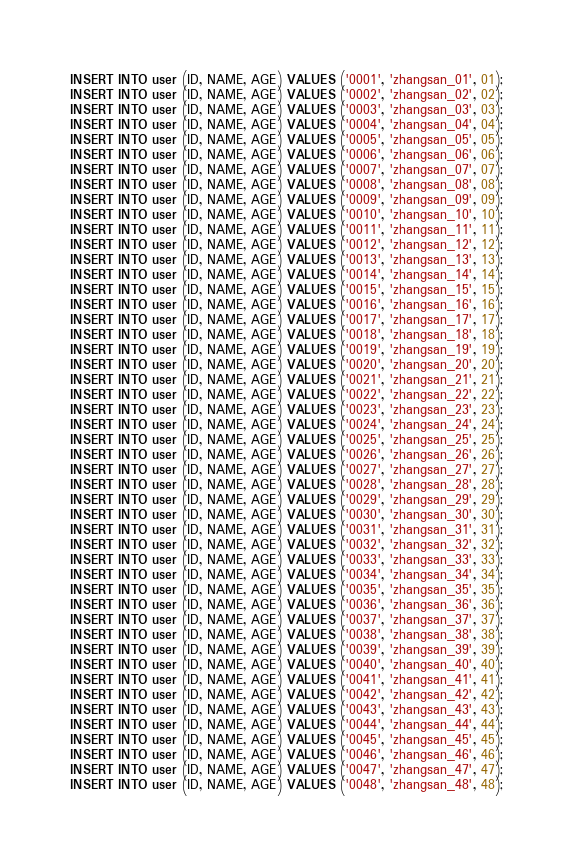<code> <loc_0><loc_0><loc_500><loc_500><_SQL_>INSERT INTO user (ID, NAME, AGE) VALUES ('0001', 'zhangsan_01', 01);
INSERT INTO user (ID, NAME, AGE) VALUES ('0002', 'zhangsan_02', 02);
INSERT INTO user (ID, NAME, AGE) VALUES ('0003', 'zhangsan_03', 03);
INSERT INTO user (ID, NAME, AGE) VALUES ('0004', 'zhangsan_04', 04);
INSERT INTO user (ID, NAME, AGE) VALUES ('0005', 'zhangsan_05', 05);
INSERT INTO user (ID, NAME, AGE) VALUES ('0006', 'zhangsan_06', 06);
INSERT INTO user (ID, NAME, AGE) VALUES ('0007', 'zhangsan_07', 07);
INSERT INTO user (ID, NAME, AGE) VALUES ('0008', 'zhangsan_08', 08);
INSERT INTO user (ID, NAME, AGE) VALUES ('0009', 'zhangsan_09', 09);
INSERT INTO user (ID, NAME, AGE) VALUES ('0010', 'zhangsan_10', 10);
INSERT INTO user (ID, NAME, AGE) VALUES ('0011', 'zhangsan_11', 11);
INSERT INTO user (ID, NAME, AGE) VALUES ('0012', 'zhangsan_12', 12);
INSERT INTO user (ID, NAME, AGE) VALUES ('0013', 'zhangsan_13', 13);
INSERT INTO user (ID, NAME, AGE) VALUES ('0014', 'zhangsan_14', 14);
INSERT INTO user (ID, NAME, AGE) VALUES ('0015', 'zhangsan_15', 15);
INSERT INTO user (ID, NAME, AGE) VALUES ('0016', 'zhangsan_16', 16);
INSERT INTO user (ID, NAME, AGE) VALUES ('0017', 'zhangsan_17', 17);
INSERT INTO user (ID, NAME, AGE) VALUES ('0018', 'zhangsan_18', 18);
INSERT INTO user (ID, NAME, AGE) VALUES ('0019', 'zhangsan_19', 19);
INSERT INTO user (ID, NAME, AGE) VALUES ('0020', 'zhangsan_20', 20);
INSERT INTO user (ID, NAME, AGE) VALUES ('0021', 'zhangsan_21', 21);
INSERT INTO user (ID, NAME, AGE) VALUES ('0022', 'zhangsan_22', 22);
INSERT INTO user (ID, NAME, AGE) VALUES ('0023', 'zhangsan_23', 23);
INSERT INTO user (ID, NAME, AGE) VALUES ('0024', 'zhangsan_24', 24);
INSERT INTO user (ID, NAME, AGE) VALUES ('0025', 'zhangsan_25', 25);
INSERT INTO user (ID, NAME, AGE) VALUES ('0026', 'zhangsan_26', 26);
INSERT INTO user (ID, NAME, AGE) VALUES ('0027', 'zhangsan_27', 27);
INSERT INTO user (ID, NAME, AGE) VALUES ('0028', 'zhangsan_28', 28);
INSERT INTO user (ID, NAME, AGE) VALUES ('0029', 'zhangsan_29', 29);
INSERT INTO user (ID, NAME, AGE) VALUES ('0030', 'zhangsan_30', 30);
INSERT INTO user (ID, NAME, AGE) VALUES ('0031', 'zhangsan_31', 31);
INSERT INTO user (ID, NAME, AGE) VALUES ('0032', 'zhangsan_32', 32);
INSERT INTO user (ID, NAME, AGE) VALUES ('0033', 'zhangsan_33', 33);
INSERT INTO user (ID, NAME, AGE) VALUES ('0034', 'zhangsan_34', 34);
INSERT INTO user (ID, NAME, AGE) VALUES ('0035', 'zhangsan_35', 35);
INSERT INTO user (ID, NAME, AGE) VALUES ('0036', 'zhangsan_36', 36);
INSERT INTO user (ID, NAME, AGE) VALUES ('0037', 'zhangsan_37', 37);
INSERT INTO user (ID, NAME, AGE) VALUES ('0038', 'zhangsan_38', 38);
INSERT INTO user (ID, NAME, AGE) VALUES ('0039', 'zhangsan_39', 39);
INSERT INTO user (ID, NAME, AGE) VALUES ('0040', 'zhangsan_40', 40);
INSERT INTO user (ID, NAME, AGE) VALUES ('0041', 'zhangsan_41', 41);
INSERT INTO user (ID, NAME, AGE) VALUES ('0042', 'zhangsan_42', 42);
INSERT INTO user (ID, NAME, AGE) VALUES ('0043', 'zhangsan_43', 43);
INSERT INTO user (ID, NAME, AGE) VALUES ('0044', 'zhangsan_44', 44);
INSERT INTO user (ID, NAME, AGE) VALUES ('0045', 'zhangsan_45', 45);
INSERT INTO user (ID, NAME, AGE) VALUES ('0046', 'zhangsan_46', 46);
INSERT INTO user (ID, NAME, AGE) VALUES ('0047', 'zhangsan_47', 47);
INSERT INTO user (ID, NAME, AGE) VALUES ('0048', 'zhangsan_48', 48);
</code> 